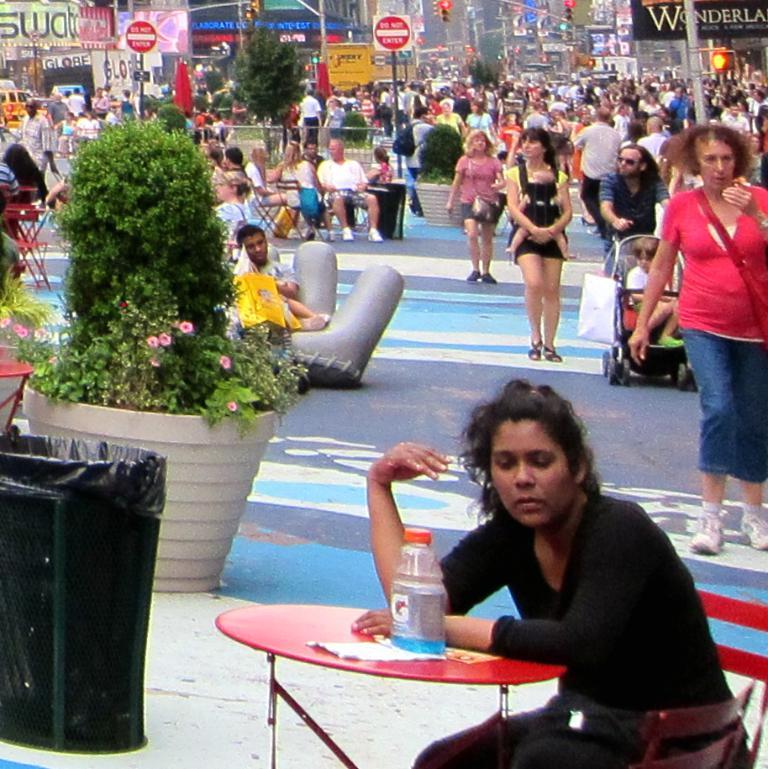What is the person in the image wearing? The person is wearing a black dress in the image. What can be seen behind the person in the black dress? There are multiple people behind the person in the black dress. What is the color of the table in front of the person? The table in front of the person is red. What time does the person in the black dress regret watching the movie in the image? There is no indication of regret or a movie in the image, so it cannot be determined from the image. 